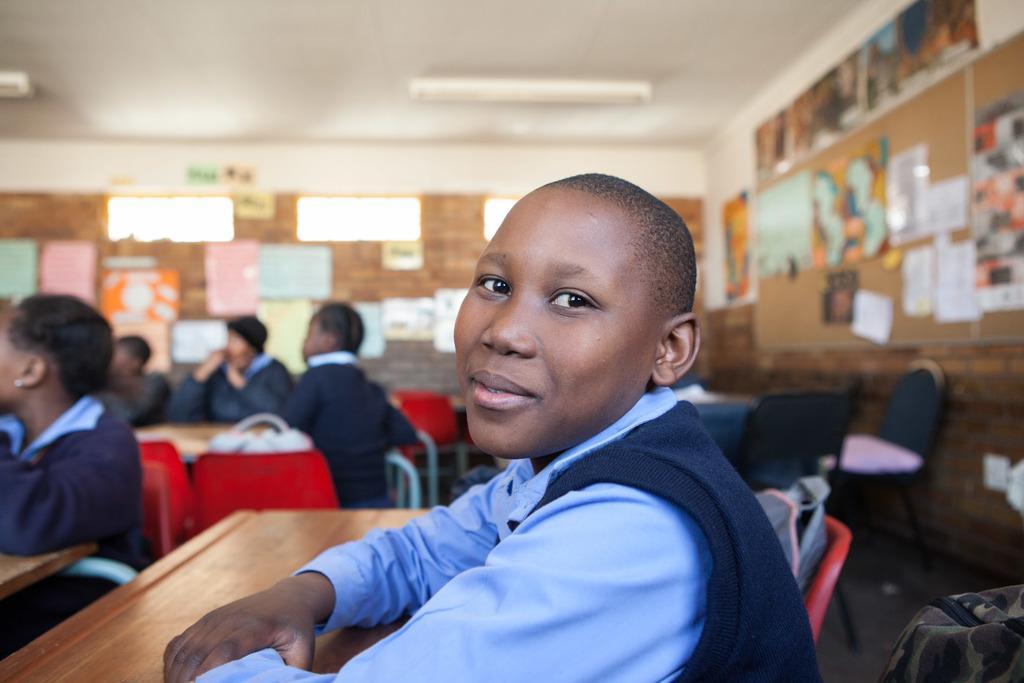Can you describe this image briefly? This image is taken inside a classroom. There are few kids in this room. In the middle of the image a girl is sitting on a chair and placing her hands on the table. At the background there is a wall with paintings and picture frames. At the top of the image there is a ceiling with lights. 